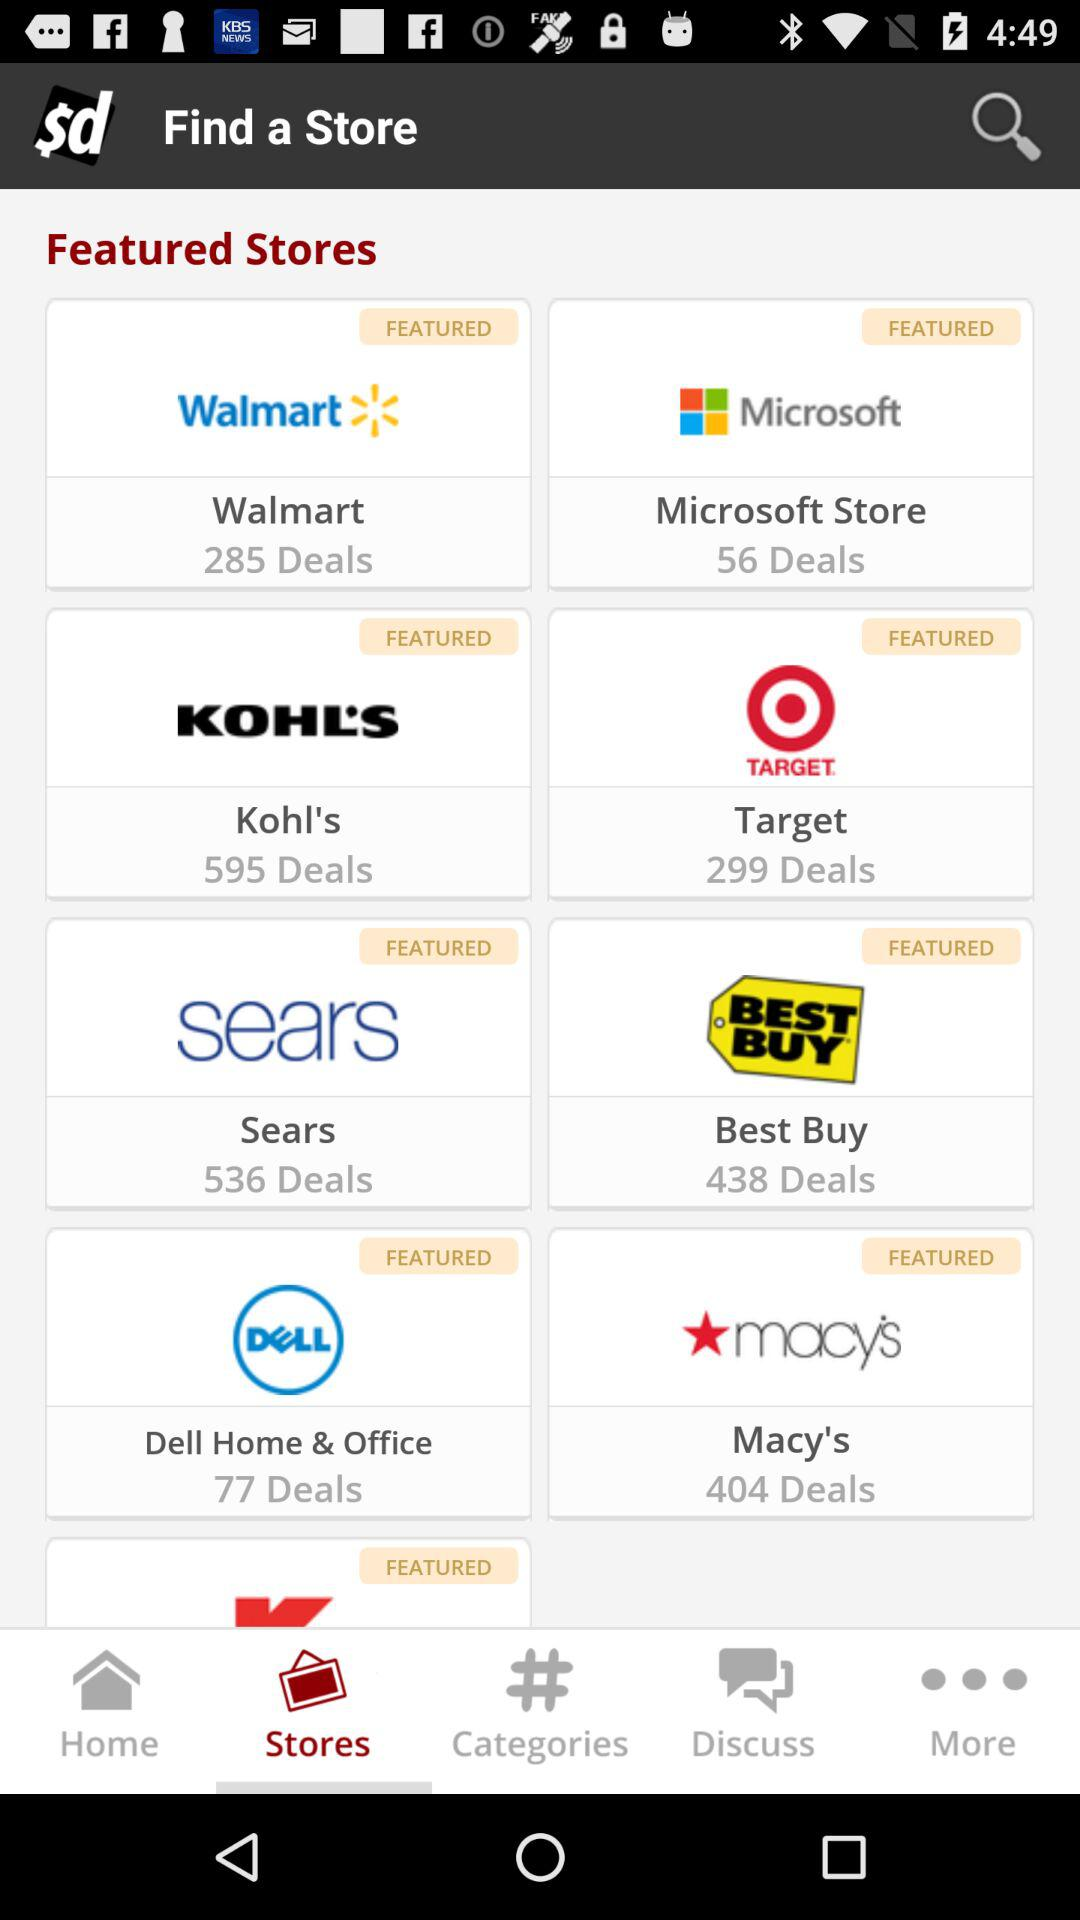What is the number of deals in "Kohl's"? The number of deals in "Kohl's" is 595. 